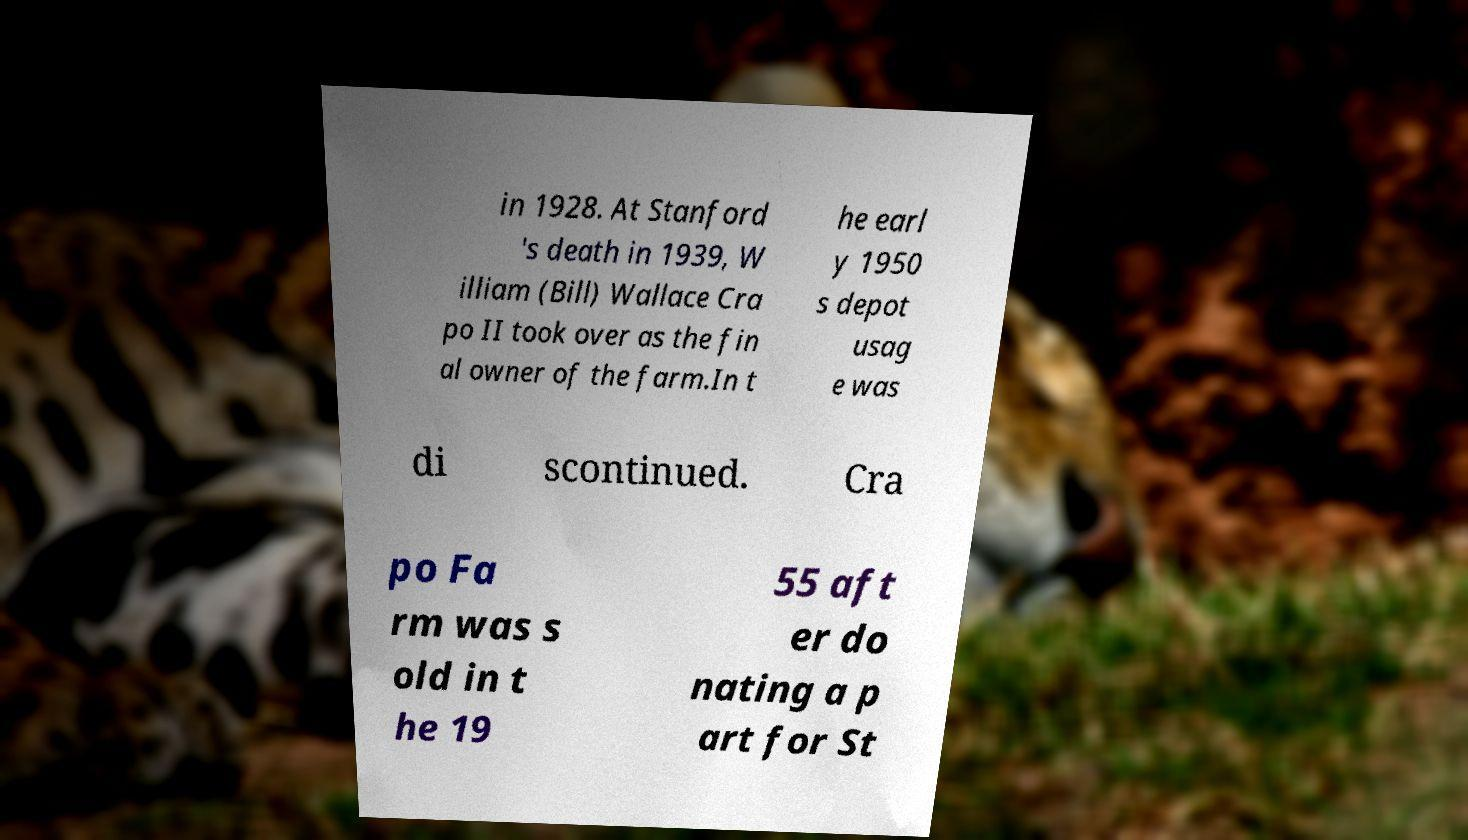For documentation purposes, I need the text within this image transcribed. Could you provide that? in 1928. At Stanford 's death in 1939, W illiam (Bill) Wallace Cra po II took over as the fin al owner of the farm.In t he earl y 1950 s depot usag e was di scontinued. Cra po Fa rm was s old in t he 19 55 aft er do nating a p art for St 